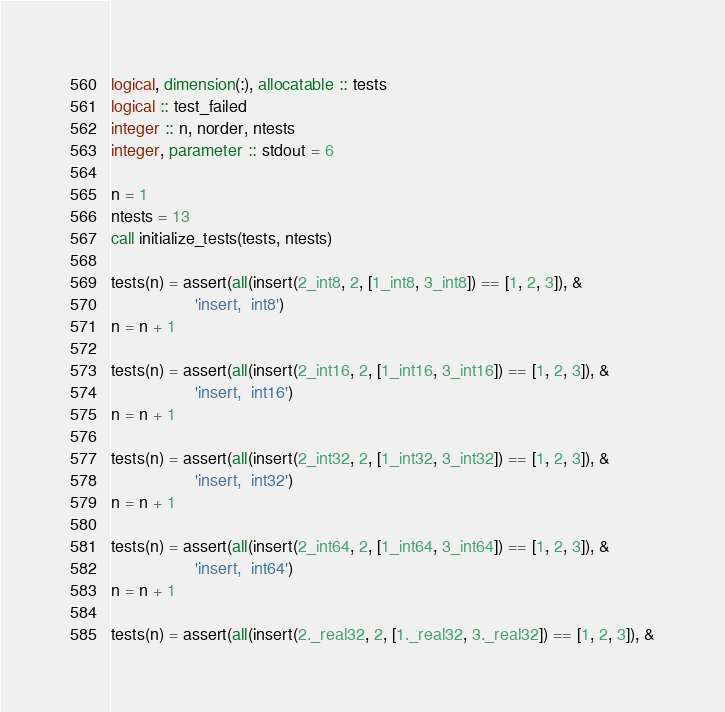<code> <loc_0><loc_0><loc_500><loc_500><_FORTRAN_>logical, dimension(:), allocatable :: tests
logical :: test_failed
integer :: n, norder, ntests
integer, parameter :: stdout = 6

n = 1
ntests = 13
call initialize_tests(tests, ntests)

tests(n) = assert(all(insert(2_int8, 2, [1_int8, 3_int8]) == [1, 2, 3]), &
                  'insert,  int8')
n = n + 1

tests(n) = assert(all(insert(2_int16, 2, [1_int16, 3_int16]) == [1, 2, 3]), &
                  'insert,  int16')
n = n + 1

tests(n) = assert(all(insert(2_int32, 2, [1_int32, 3_int32]) == [1, 2, 3]), &
                  'insert,  int32')
n = n + 1

tests(n) = assert(all(insert(2_int64, 2, [1_int64, 3_int64]) == [1, 2, 3]), &
                  'insert,  int64')
n = n + 1

tests(n) = assert(all(insert(2._real32, 2, [1._real32, 3._real32]) == [1, 2, 3]), &</code> 